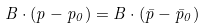<formula> <loc_0><loc_0><loc_500><loc_500>B \cdot ( p - p _ { 0 } ) = B \cdot ( \bar { p } - \bar { p } _ { 0 } )</formula> 